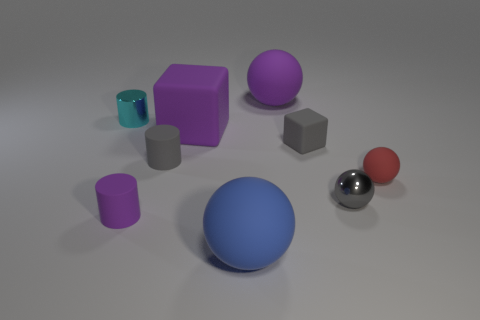Subtract 1 balls. How many balls are left? 3 Subtract all spheres. How many objects are left? 5 Add 6 large blue shiny cylinders. How many large blue shiny cylinders exist? 6 Subtract 1 purple balls. How many objects are left? 8 Subtract all small cyan metallic objects. Subtract all small cyan things. How many objects are left? 7 Add 8 purple cylinders. How many purple cylinders are left? 9 